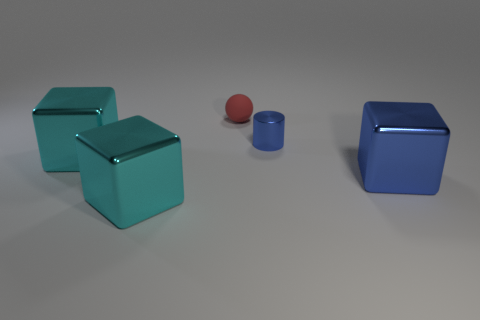Subtract all big cyan cubes. How many cubes are left? 1 Subtract all red balls. How many cyan cubes are left? 2 Add 3 big brown rubber blocks. How many objects exist? 8 Subtract all blocks. How many objects are left? 2 Subtract 0 cyan cylinders. How many objects are left? 5 Subtract all gray cubes. Subtract all red cylinders. How many cubes are left? 3 Subtract all large shiny things. Subtract all cyan rubber cubes. How many objects are left? 2 Add 4 cylinders. How many cylinders are left? 5 Add 4 large red metallic balls. How many large red metallic balls exist? 4 